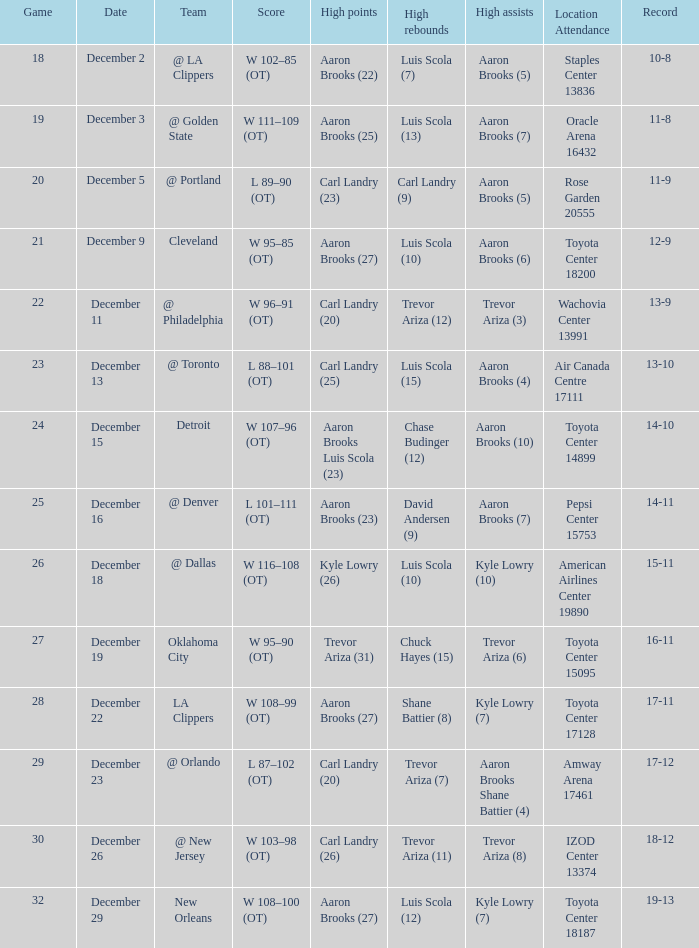Where was the game in which Carl Landry (25) did the most high points played? Air Canada Centre 17111. 